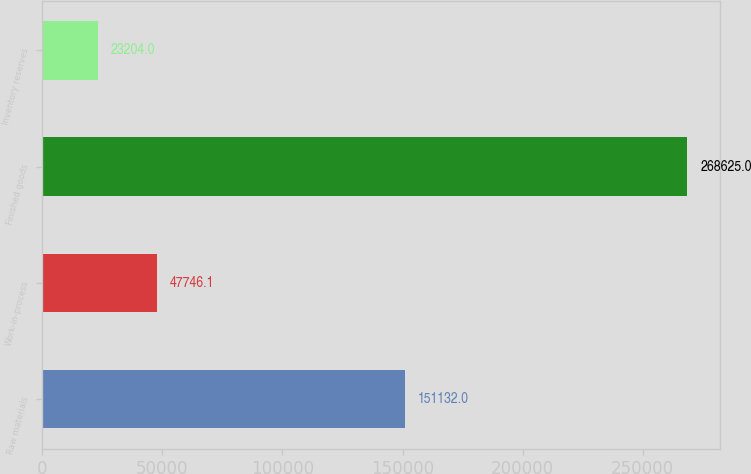Convert chart to OTSL. <chart><loc_0><loc_0><loc_500><loc_500><bar_chart><fcel>Raw materials<fcel>Work-in-process<fcel>Finished goods<fcel>Inventory reserves<nl><fcel>151132<fcel>47746.1<fcel>268625<fcel>23204<nl></chart> 